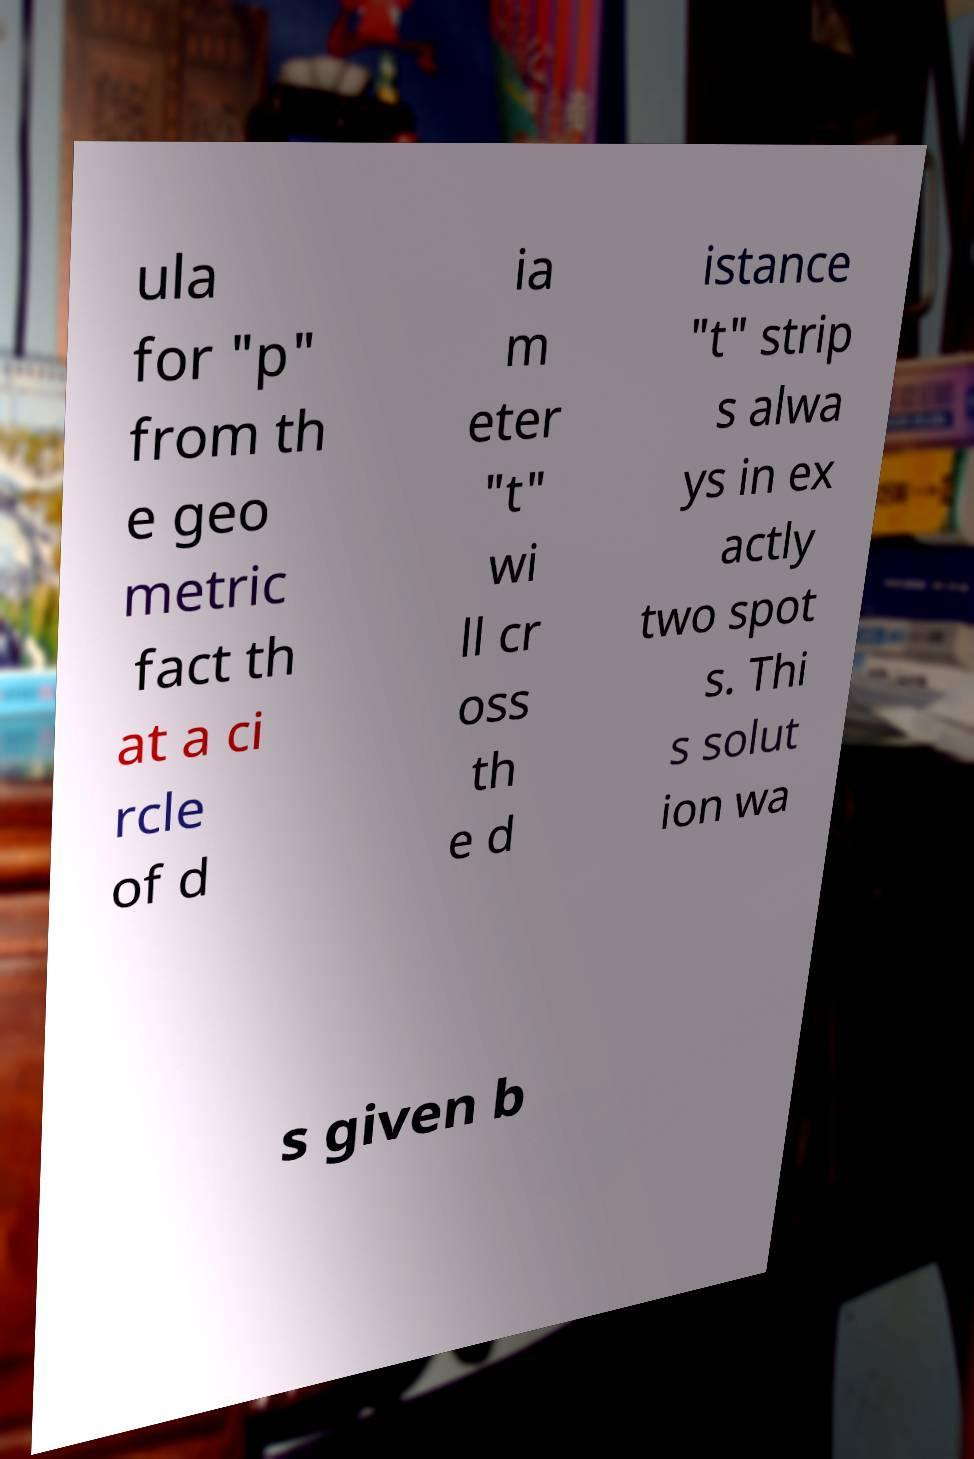What messages or text are displayed in this image? I need them in a readable, typed format. ula for "p" from th e geo metric fact th at a ci rcle of d ia m eter "t" wi ll cr oss th e d istance "t" strip s alwa ys in ex actly two spot s. Thi s solut ion wa s given b 